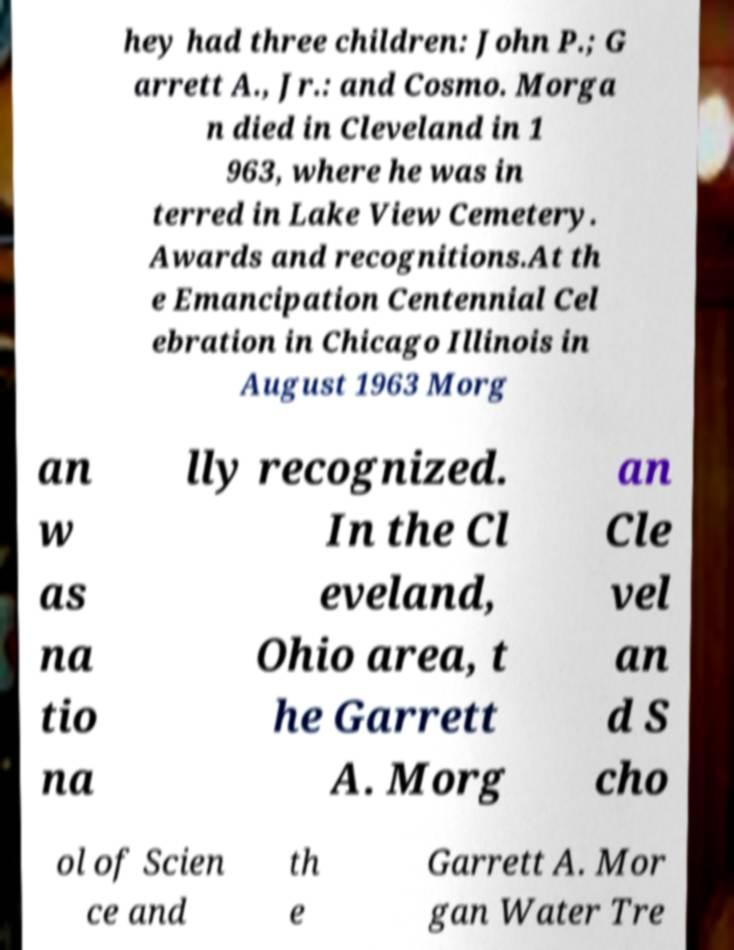Can you accurately transcribe the text from the provided image for me? hey had three children: John P.; G arrett A., Jr.: and Cosmo. Morga n died in Cleveland in 1 963, where he was in terred in Lake View Cemetery. Awards and recognitions.At th e Emancipation Centennial Cel ebration in Chicago Illinois in August 1963 Morg an w as na tio na lly recognized. In the Cl eveland, Ohio area, t he Garrett A. Morg an Cle vel an d S cho ol of Scien ce and th e Garrett A. Mor gan Water Tre 